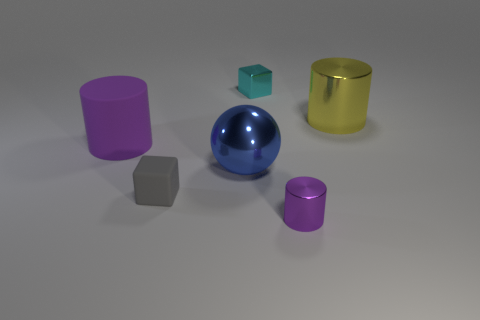Add 3 large cyan rubber cylinders. How many objects exist? 9 Subtract all cubes. How many objects are left? 4 Subtract 0 purple blocks. How many objects are left? 6 Subtract all tiny balls. Subtract all blue objects. How many objects are left? 5 Add 4 blue things. How many blue things are left? 5 Add 3 cyan objects. How many cyan objects exist? 4 